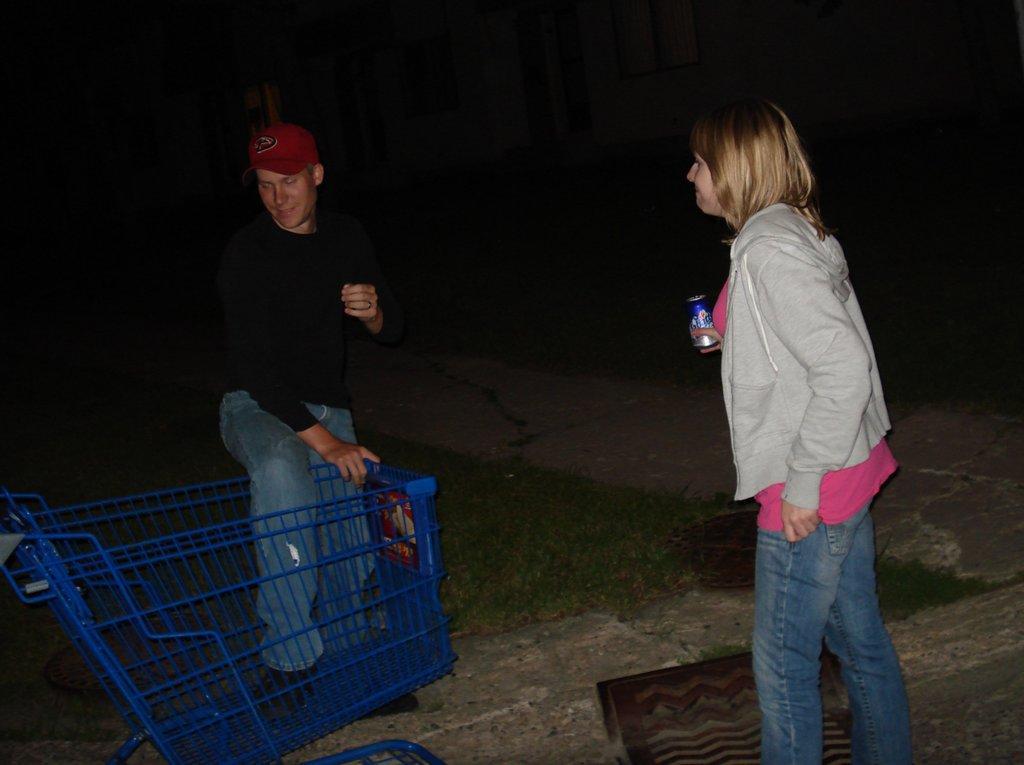Please provide a concise description of this image. In this image, we can see two people. A woman is holding a tin and man is kept his leg in the cart. Here we can see a walkway and grass. Top of the image, we can see houses. Dark view we can see. 